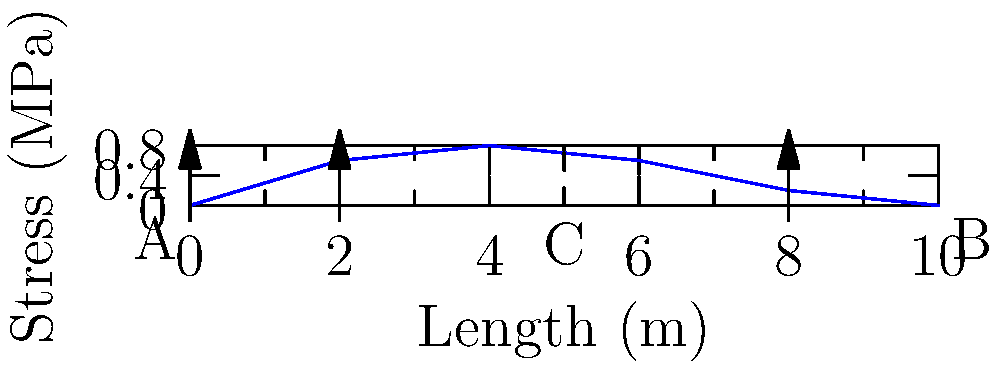As a researcher studying unconventional theories of dinosaur extinction, you're exploring the possibility that massive geological events could have altered Earth's stress distribution. Consider a simplified model of Earth's crust as a beam AB of length 10 m, with three upward point loads at points A, 2 m from A, and 8 m from A. The stress distribution along the beam is shown in the graph. What is the maximum stress experienced by the beam, and at what point does it occur? To solve this problem, we need to analyze the stress distribution graph carefully:

1. The x-axis represents the length of the beam from 0 to 10 m.
2. The y-axis represents the stress in MPa.
3. The blue curve shows the stress distribution along the beam.

To find the maximum stress:

1. Observe the curve's shape: It rises from point A, reaches a peak, then descends to point B.
2. The peak of the curve represents the maximum stress.
3. From the graph, we can estimate that the peak occurs at x = 4 m (point C).
4. The y-value at this peak is approximately 0.8 MPa.

Therefore, the maximum stress is about 0.8 MPa and occurs at 4 m from point A (or at point C).

This stress distribution could be analogous to how tectonic forces might have affected Earth's crust during a catastrophic event, potentially contributing to dinosaur extinction through geological upheaval.
Answer: 0.8 MPa at 4 m from A 